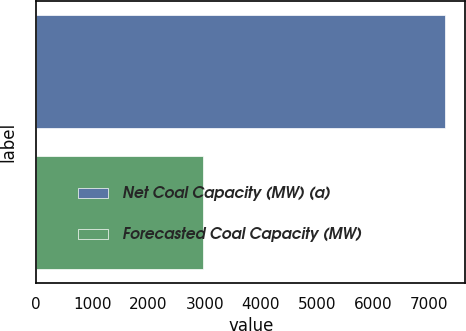Convert chart. <chart><loc_0><loc_0><loc_500><loc_500><bar_chart><fcel>Net Coal Capacity (MW) (a)<fcel>Forecasted Coal Capacity (MW)<nl><fcel>7280<fcel>2971<nl></chart> 